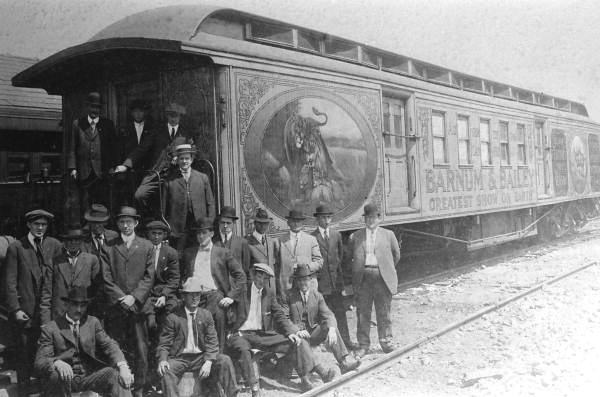Identify the text displayed in this image. BARNUM 